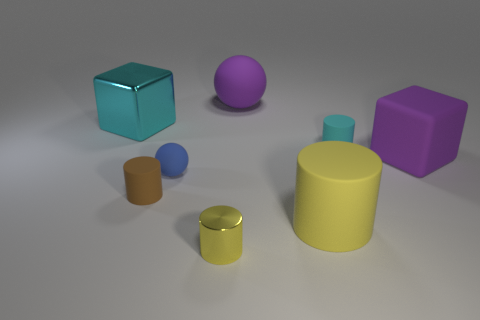What number of big objects are behind the tiny cyan object and right of the small brown rubber cylinder?
Your response must be concise. 1. Do the big yellow thing and the big purple thing that is right of the large yellow rubber object have the same material?
Provide a succinct answer. Yes. Are there the same number of big yellow cylinders that are in front of the metallic cylinder and large gray rubber objects?
Your answer should be compact. Yes. There is a small metallic object that is to the left of the small cyan matte cylinder; what is its color?
Your answer should be compact. Yellow. How many other objects are the same color as the large cylinder?
Your response must be concise. 1. Is there any other thing that is the same size as the brown cylinder?
Your response must be concise. Yes. There is a matte cylinder to the left of the purple rubber sphere; does it have the same size as the big yellow thing?
Keep it short and to the point. No. What is the thing that is in front of the big yellow cylinder made of?
Your answer should be compact. Metal. Is there any other thing that is the same shape as the small cyan object?
Provide a short and direct response. Yes. How many matte things are large purple things or brown things?
Make the answer very short. 3. 